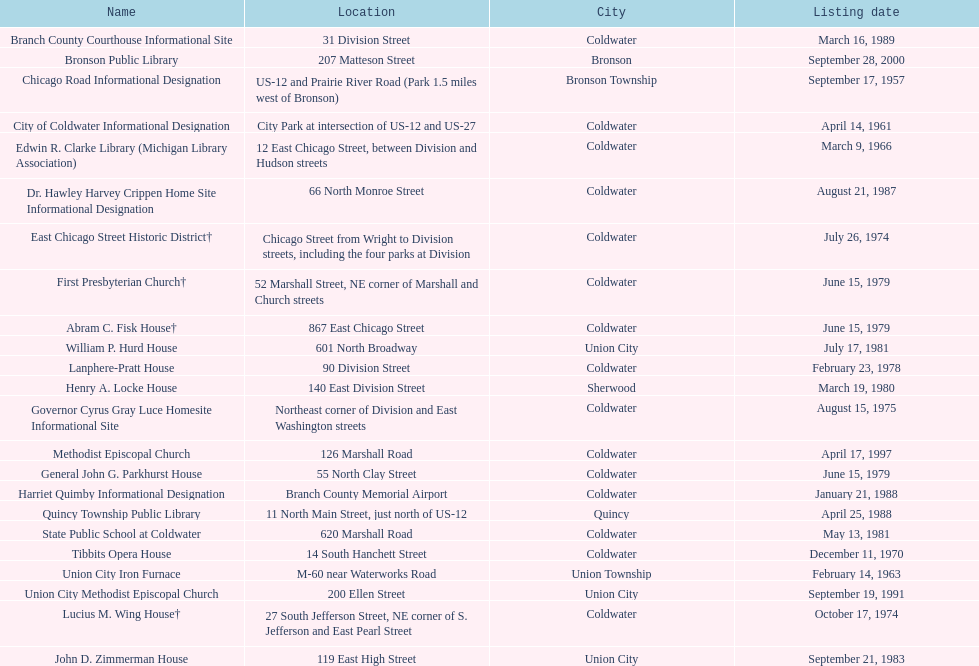How many historic sites were listed in 1988? 2. 